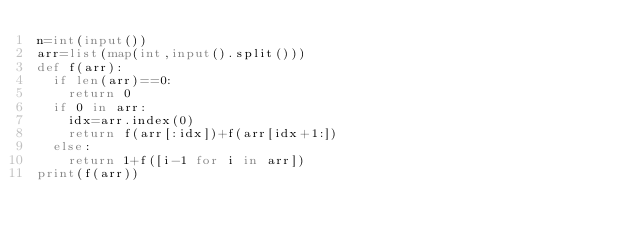Convert code to text. <code><loc_0><loc_0><loc_500><loc_500><_Python_>n=int(input())
arr=list(map(int,input().split()))
def f(arr):
  if len(arr)==0:
    return 0
  if 0 in arr:
    idx=arr.index(0)
    return f(arr[:idx])+f(arr[idx+1:])
  else:
    return 1+f([i-1 for i in arr])
print(f(arr))</code> 